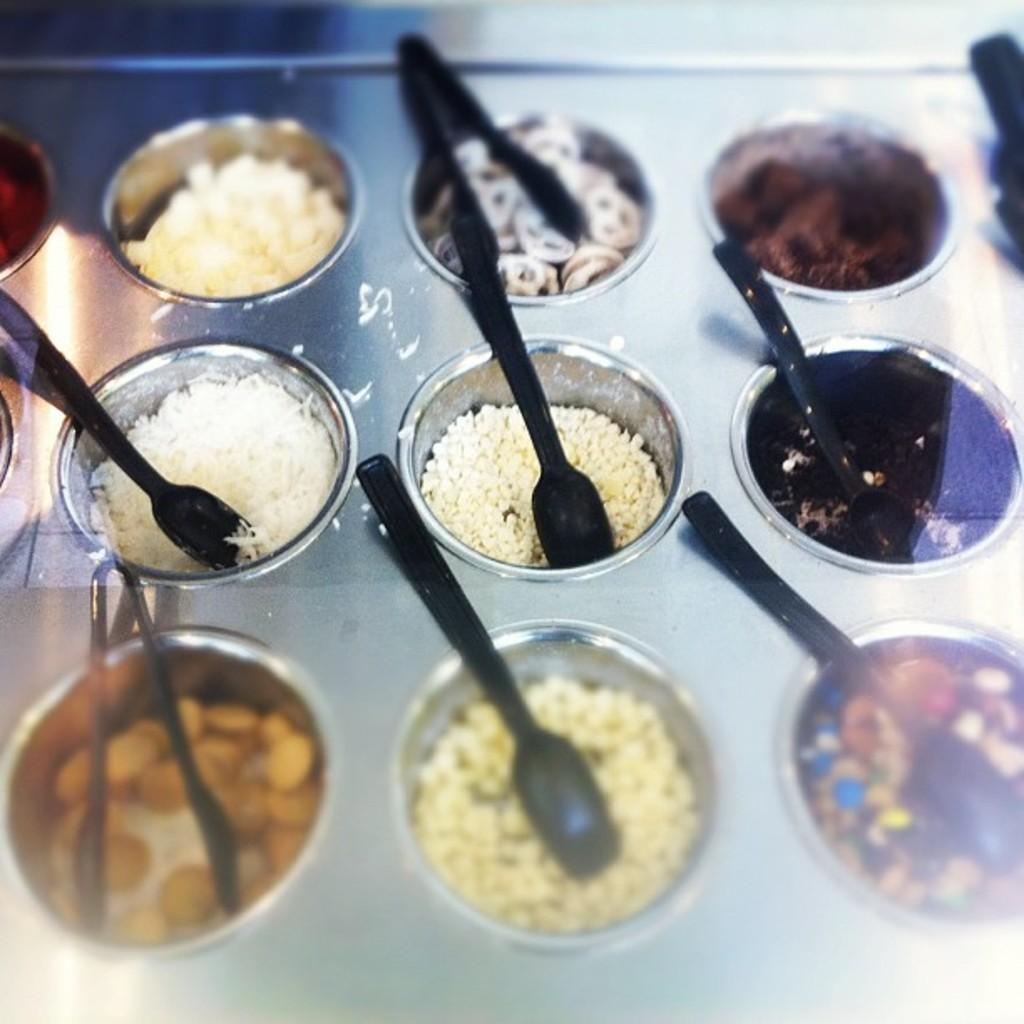What can be found in the utensils in the image? There is food in utensils in the image. What type of utensils are visible in the image? There are spoons visible in the image. Can you see any bees buzzing around the food in the image? There are no bees present in the image. Is there a zoo visible in the background of the image? There is no zoo present in the image. 